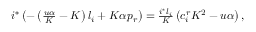<formula> <loc_0><loc_0><loc_500><loc_500>\begin{array} { r } { i ^ { * } \left ( - \left ( \frac { u \alpha } { K } - K \right ) l _ { i } + K \alpha p _ { r } \right ) = \frac { i ^ { * } l _ { i } } { K } \left ( c _ { i } ^ { r } K ^ { 2 } - { u \alpha } \right ) , } \end{array}</formula> 